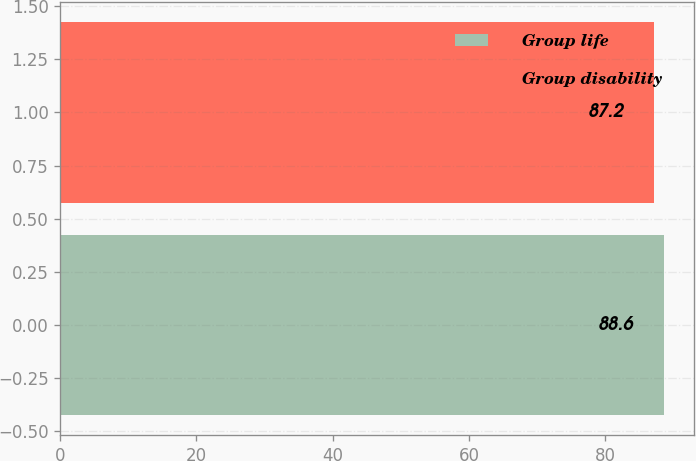Convert chart. <chart><loc_0><loc_0><loc_500><loc_500><bar_chart><fcel>Group life<fcel>Group disability<nl><fcel>88.6<fcel>87.2<nl></chart> 